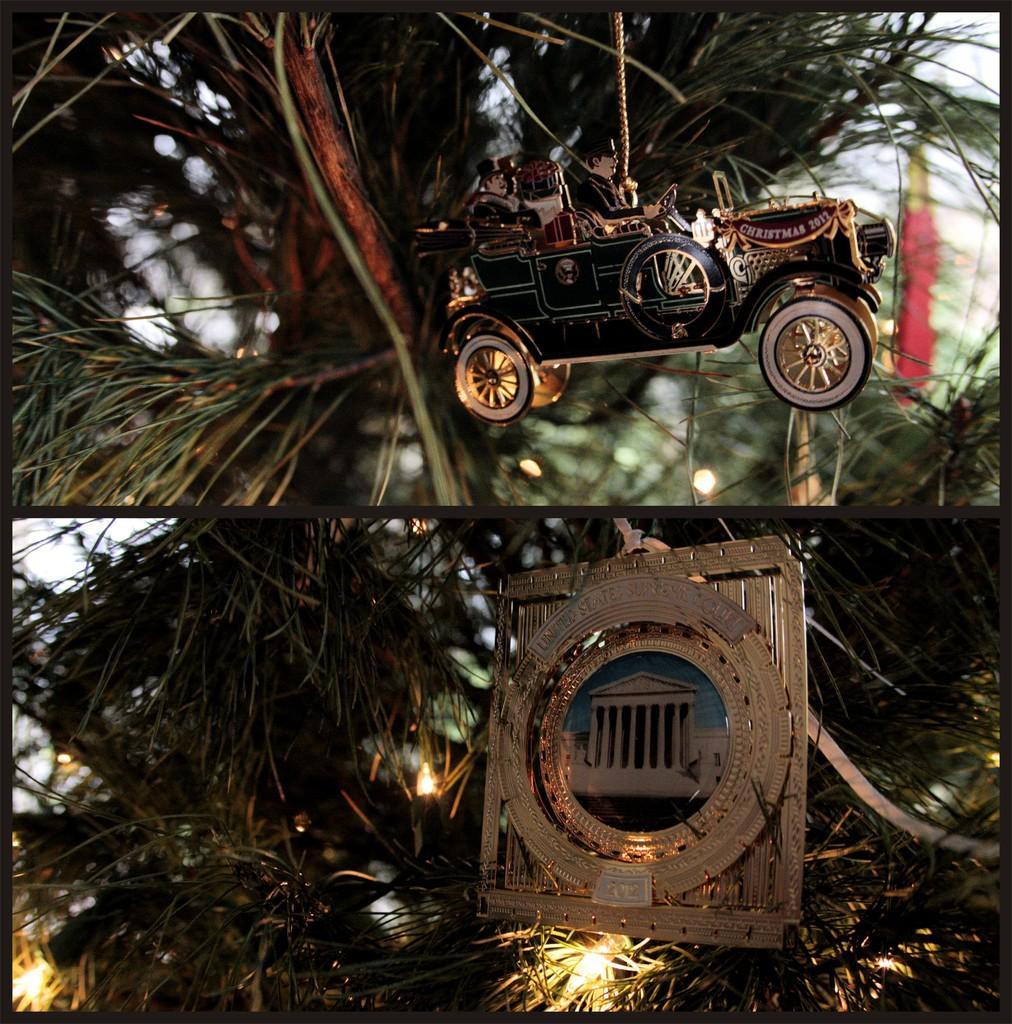Can you describe this image briefly? This is a collage picture. Here we can see a toy vehicle, frame, lights, trees, and sky. 